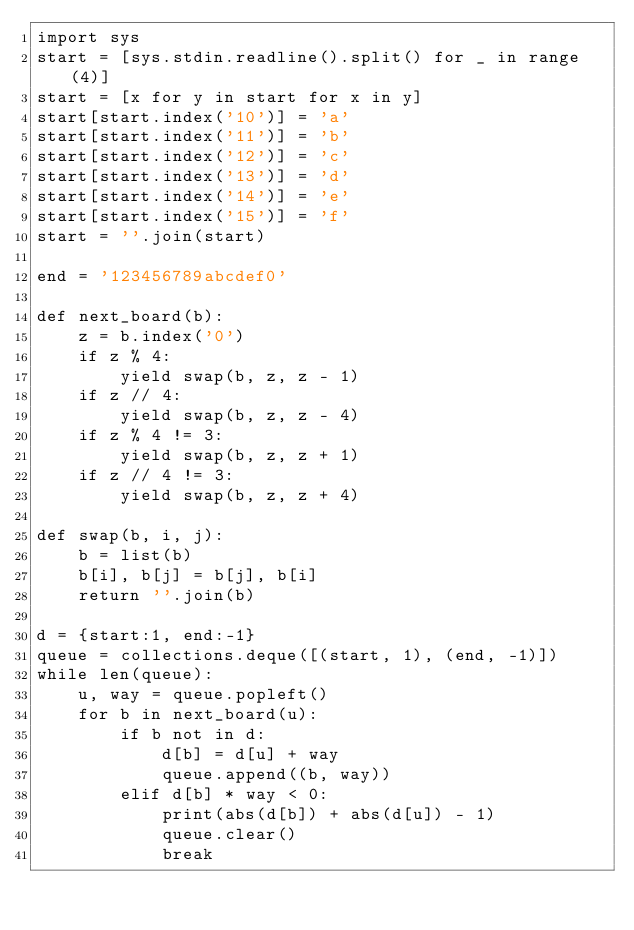<code> <loc_0><loc_0><loc_500><loc_500><_Python_>import sys
start = [sys.stdin.readline().split() for _ in range(4)]
start = [x for y in start for x in y]
start[start.index('10')] = 'a'
start[start.index('11')] = 'b'
start[start.index('12')] = 'c'
start[start.index('13')] = 'd'
start[start.index('14')] = 'e'
start[start.index('15')] = 'f'
start = ''.join(start)

end = '123456789abcdef0'

def next_board(b):
    z = b.index('0')
    if z % 4:
        yield swap(b, z, z - 1)
    if z // 4:
        yield swap(b, z, z - 4)
    if z % 4 != 3:
        yield swap(b, z, z + 1)
    if z // 4 != 3:
        yield swap(b, z, z + 4)

def swap(b, i, j):
    b = list(b)
    b[i], b[j] = b[j], b[i]
    return ''.join(b)
        
d = {start:1, end:-1}
queue = collections.deque([(start, 1), (end, -1)])
while len(queue):
    u, way = queue.popleft()
    for b in next_board(u):
        if b not in d:
            d[b] = d[u] + way
            queue.append((b, way))
        elif d[b] * way < 0:
            print(abs(d[b]) + abs(d[u]) - 1)
            queue.clear()
            break</code> 